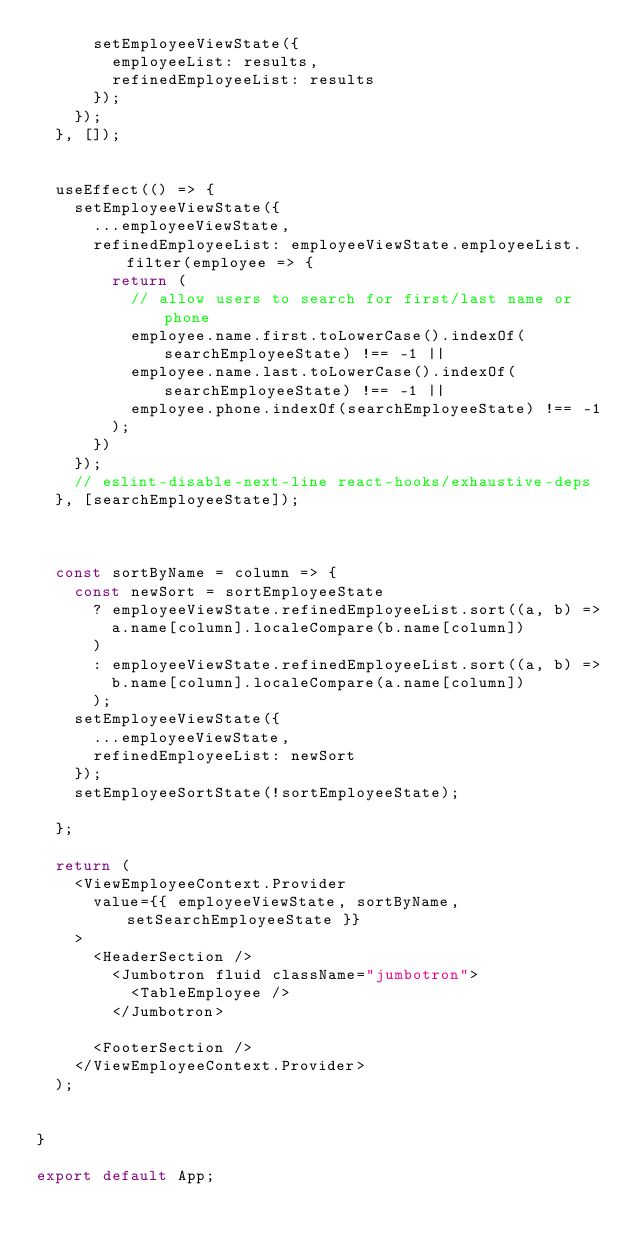<code> <loc_0><loc_0><loc_500><loc_500><_JavaScript_>      setEmployeeViewState({
        employeeList: results,
        refinedEmployeeList: results
      });
    });
  }, []);


  useEffect(() => {
    setEmployeeViewState({
      ...employeeViewState,
      refinedEmployeeList: employeeViewState.employeeList.filter(employee => {
        return (
          // allow users to search for first/last name or phone
          employee.name.first.toLowerCase().indexOf(searchEmployeeState) !== -1 ||
          employee.name.last.toLowerCase().indexOf(searchEmployeeState) !== -1 ||
          employee.phone.indexOf(searchEmployeeState) !== -1
        );
      })
    });
    // eslint-disable-next-line react-hooks/exhaustive-deps
  }, [searchEmployeeState]);



  const sortByName = column => {
    const newSort = sortEmployeeState
      ? employeeViewState.refinedEmployeeList.sort((a, b) =>
        a.name[column].localeCompare(b.name[column])
      )
      : employeeViewState.refinedEmployeeList.sort((a, b) =>
        b.name[column].localeCompare(a.name[column])
      );
    setEmployeeViewState({
      ...employeeViewState,
      refinedEmployeeList: newSort
    });
    setEmployeeSortState(!sortEmployeeState);

  };

  return (
    <ViewEmployeeContext.Provider
      value={{ employeeViewState, sortByName, setSearchEmployeeState }}
    >
      <HeaderSection />
        <Jumbotron fluid className="jumbotron">
          <TableEmployee />
        </Jumbotron>

      <FooterSection />
    </ViewEmployeeContext.Provider>
  );


}

export default App;

</code> 